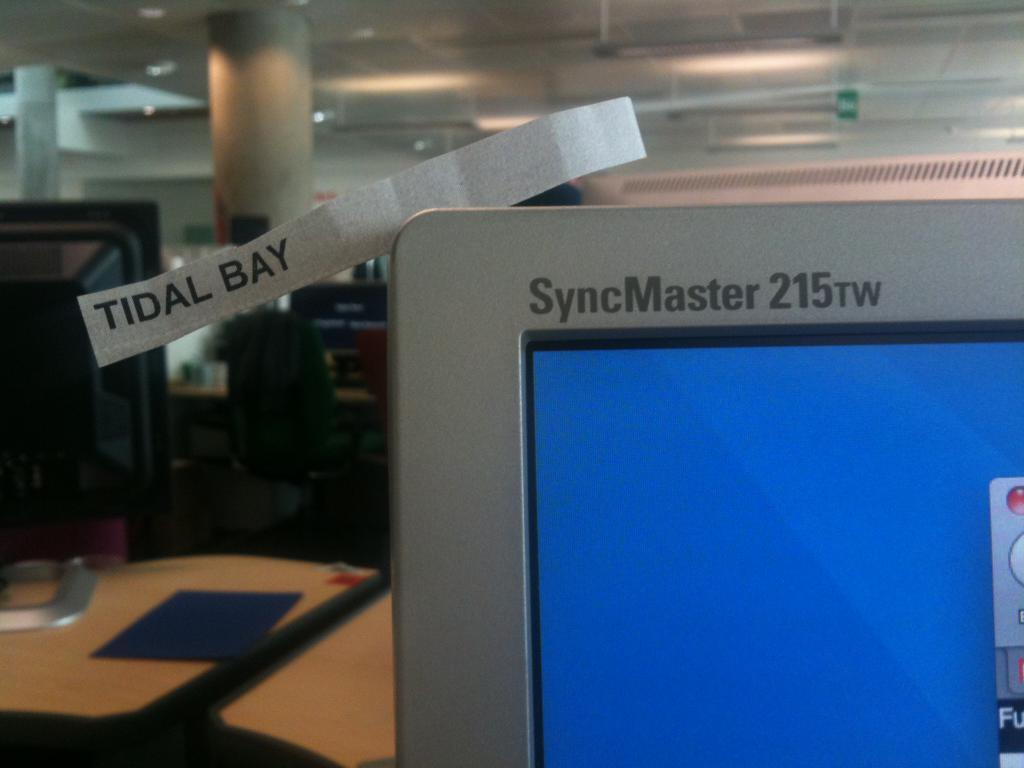<image>
Offer a succinct explanation of the picture presented. Someone has put a small label that says "tidal bay" on the corner of a computer screen. 